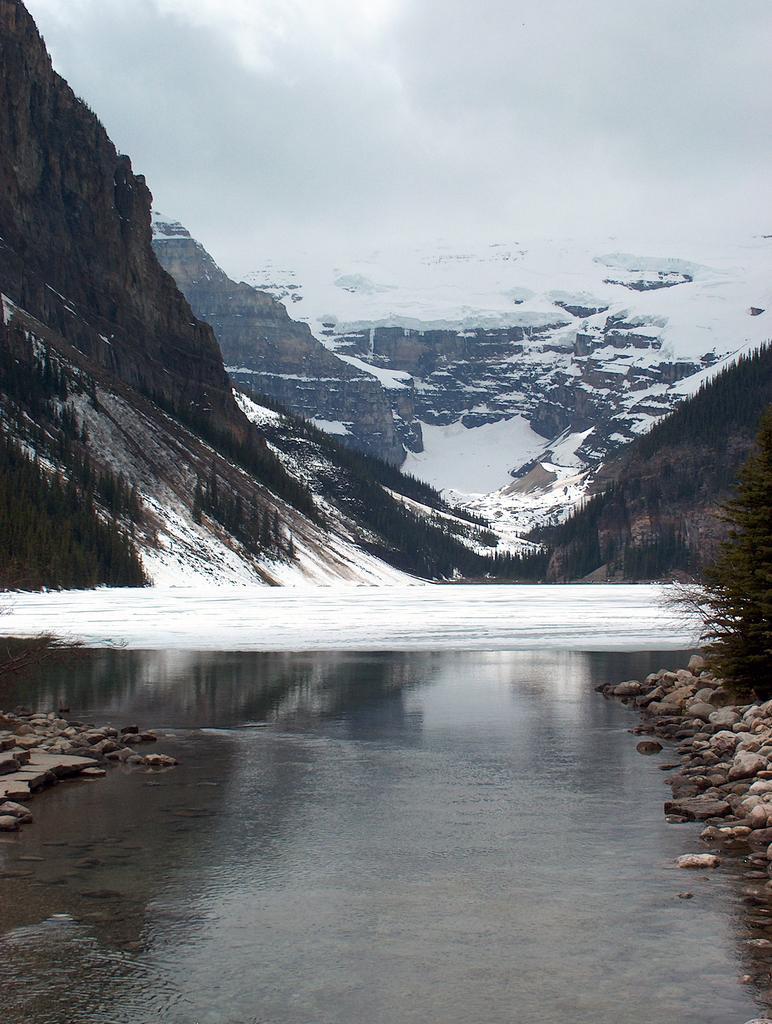Please provide a concise description of this image. In this image there is water in the middle. In the background there are snow mountains. There are stones on either side of the image. On the right side there is a tree. In the middle we can see there is snow. 